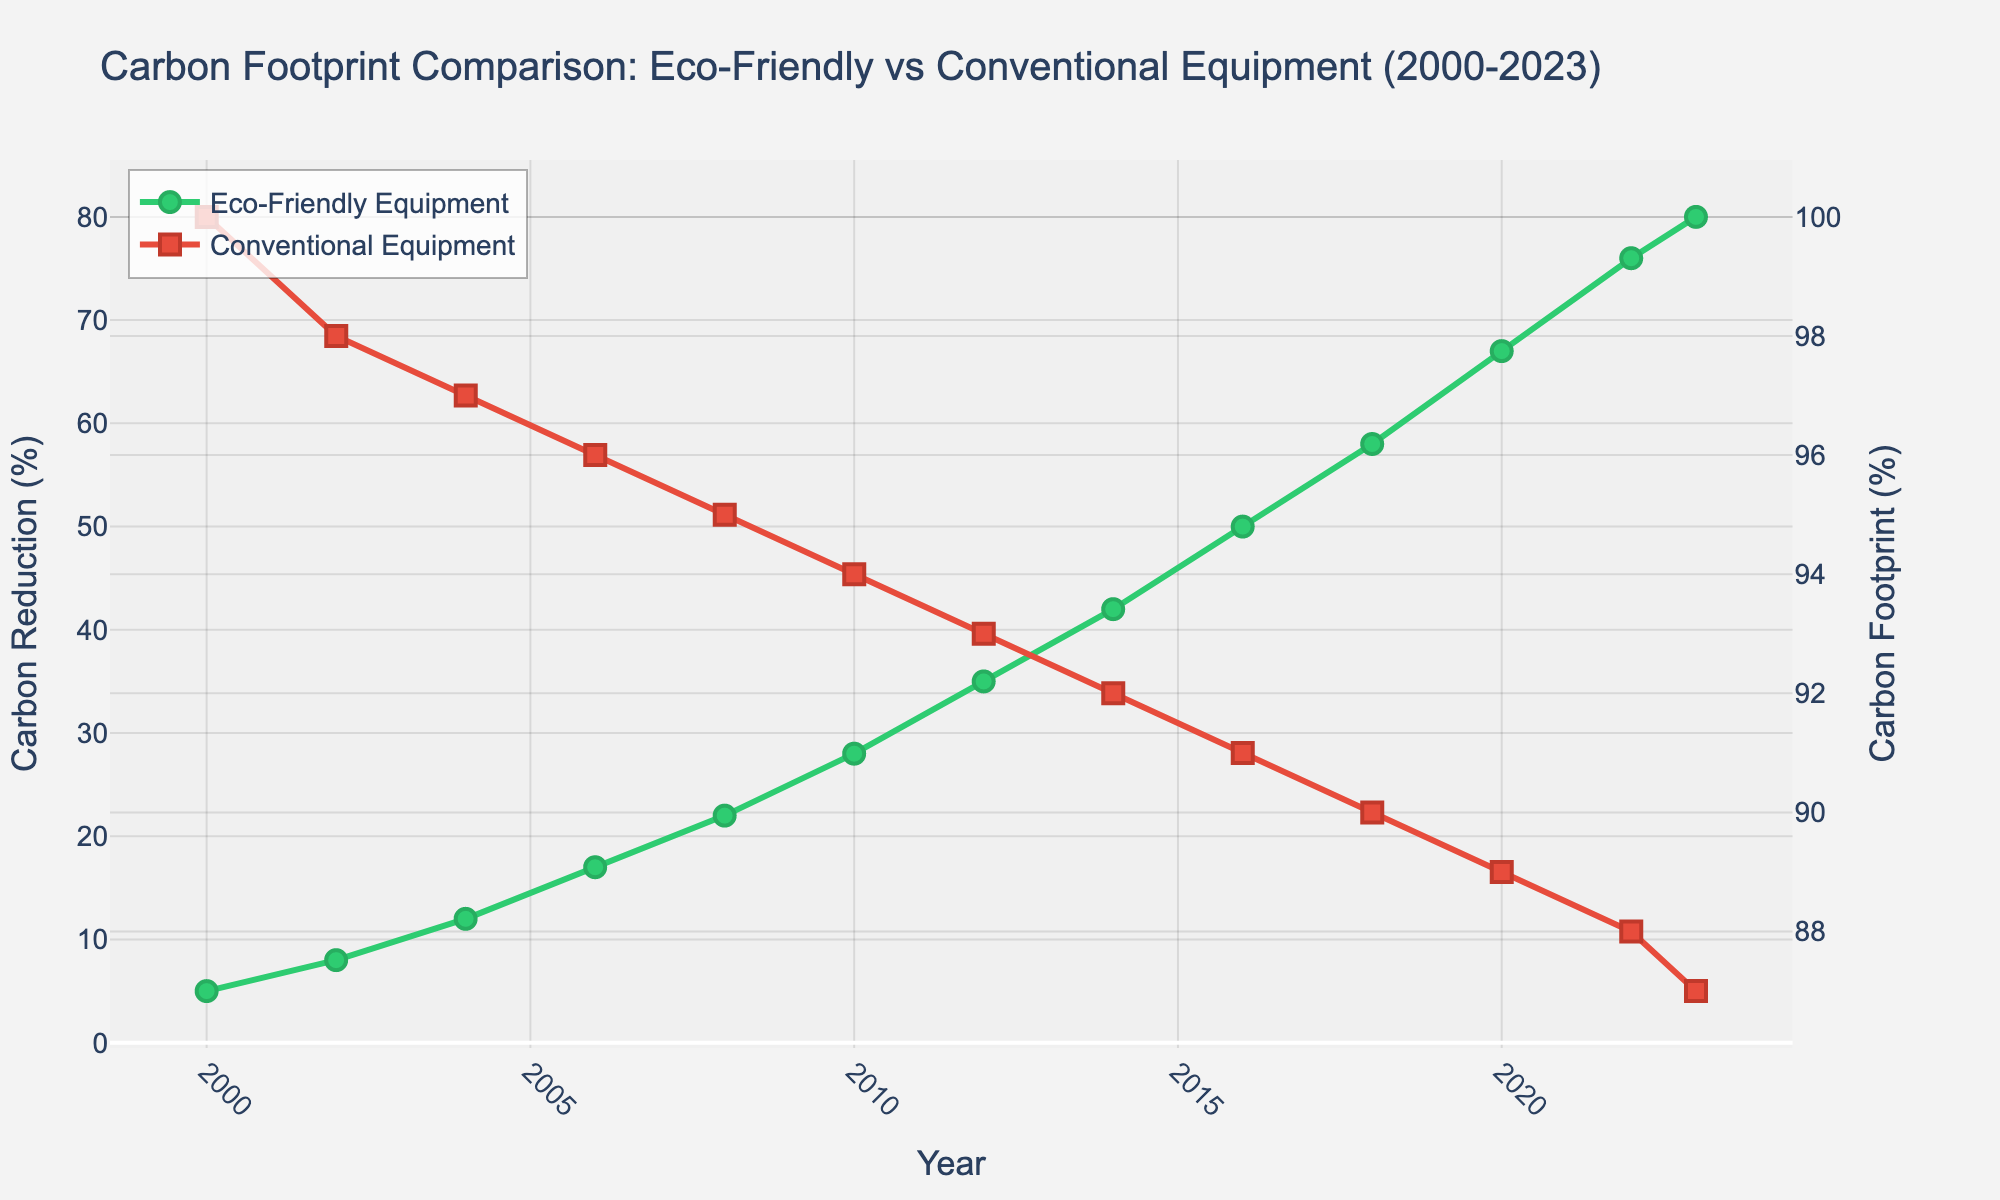What's the percentage reduction in carbon footprint achieved by eco-friendly equipment in 2023 compared to 2000? Subtract the 2000 value (5%) from the 2023 value (80%), then calculate the reduction percentage: ((80 - 5) / 100) * 100 = 75%.
Answer: 75% Has the carbon footprint percentage of conventional equipment shown a significant trend from 2000 to 2023? Observing the conventional equipment line, it continuously decreases from 100% in 2000 to 87% in 2023, indicating a significant decreasing trend over the years.
Answer: Yes Between 2010 and 2020, in which year did eco-friendly equipment achieve the highest carbon reduction percentage? Looking at the eco-friendly equipment line between 2010 and 2020, the highest value is at 2020 with 67%.
Answer: 2020 By how much did the carbon footprint of conventional equipment decrease from 2000 to 2023? Subtract the 2023 value (87%) from the 2000 value (100%): 100% - 87% = 13%.
Answer: 13% What is the average carbon reduction percentage achieved by eco-friendly equipment every four years from 2000 to 2020? Calculate the average of the values for 2000, 2004, 2008, 2012, 2016, and 2020: (5 + 12 + 22 + 35 + 50 + 67) / 6 = 191 / 6 = 31.83%.
Answer: 31.83% How did the carbon reduction percentage of eco-friendly equipment in 2016 compare to the carbon footprint percentage of conventional equipment in the same year? In 2016, eco-friendly equipment achieved a 50% reduction, while conventional equipment had a 91% footprint. The difference is 91% - 50% = 41%.
Answer: 41% What is the rate of increase in carbon reduction percentage for eco-friendly equipment between each recorded year? Subtract each successive year's value and find the differences: 2002-2000 (8%-5% = 3%), 2004-2002 (12%-8% = 4%), 2006-2004 (17%-12% = 5%), 2008-2006 (22%-17% = 5%), 2010-2008 (28%-22% = 6%), 2012-2010 (35%-28% = 7%), 2014-2012 (42%-35% = 7%), 2016-2014 (50%-42% = 8%), 2018-2016 (58%-50% = 8%), 2020-2018 (67%-58% = 9%), 2022-2020 (76%-67% = 9%), 2023-2022 (80%-76% = 4%). List all the rates: [3%, 4%, 5%, 5%, 6%, 7%, 7%, 8%, 8%, 9%, 9%, 4%].
Answer: [3%, 4%, 5%, 5%, 6%, 7%, 7%, 8%, 8%, 9%, 9%, 4%] In which year did eco-friendly equipment and conventional equipment have an equal but opposite trend in carbon reduction and carbon footprint, and what were the values? Look for the year where the values of the two lines cross or significantly mirror each other. In 2004, eco-friendly equipment had a 12% reduction while conventional equipment had a 97% footprint.
Answer: 2004, 12% and 97% By how much did the carbon footprint of conventional equipment exceed eco-friendly equipment's carbon reduction in 2008? In 2008, conventional equipment had a 95% footprint and eco-friendly equipment had a 22% reduction. Difference: 95% - 22% = 73%.
Answer: 73% Which equipment shows a more consistent change over the years: eco-friendly equipment or conventional equipment? By observing the slopes of both lines, eco-friendly equipment shows a steadily increasing reduction percentage, while conventional equipment shows a slight but consistent decrease. Therefore, eco-friendly equipment shows more consistent change.
Answer: Eco-friendly equipment 